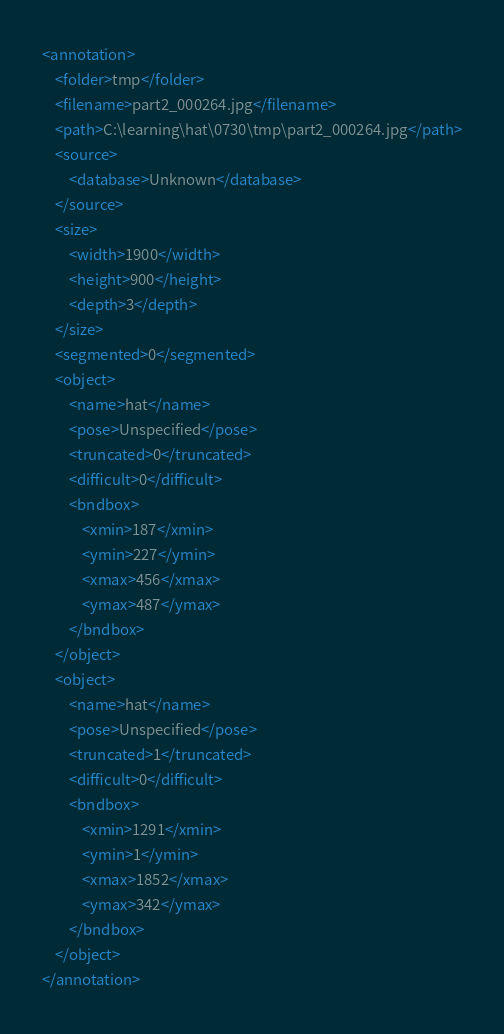Convert code to text. <code><loc_0><loc_0><loc_500><loc_500><_XML_><annotation>
	<folder>tmp</folder>
	<filename>part2_000264.jpg</filename>
	<path>C:\learning\hat\0730\tmp\part2_000264.jpg</path>
	<source>
		<database>Unknown</database>
	</source>
	<size>
		<width>1900</width>
		<height>900</height>
		<depth>3</depth>
	</size>
	<segmented>0</segmented>
	<object>
		<name>hat</name>
		<pose>Unspecified</pose>
		<truncated>0</truncated>
		<difficult>0</difficult>
		<bndbox>
			<xmin>187</xmin>
			<ymin>227</ymin>
			<xmax>456</xmax>
			<ymax>487</ymax>
		</bndbox>
	</object>
	<object>
		<name>hat</name>
		<pose>Unspecified</pose>
		<truncated>1</truncated>
		<difficult>0</difficult>
		<bndbox>
			<xmin>1291</xmin>
			<ymin>1</ymin>
			<xmax>1852</xmax>
			<ymax>342</ymax>
		</bndbox>
	</object>
</annotation>
</code> 